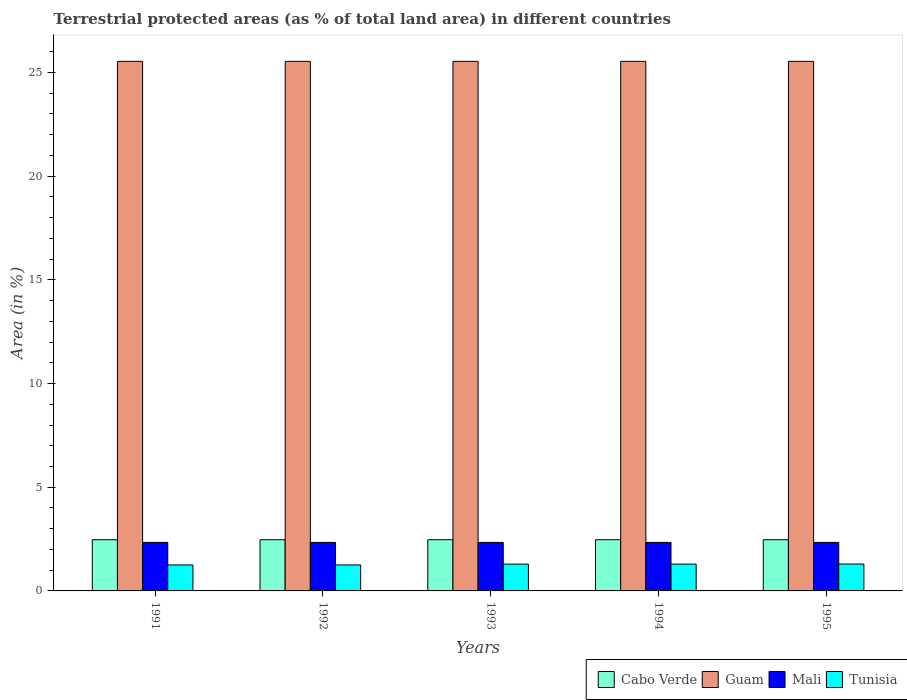How many groups of bars are there?
Keep it short and to the point. 5. How many bars are there on the 2nd tick from the left?
Offer a very short reply. 4. What is the label of the 1st group of bars from the left?
Make the answer very short. 1991. In how many cases, is the number of bars for a given year not equal to the number of legend labels?
Offer a very short reply. 0. What is the percentage of terrestrial protected land in Tunisia in 1995?
Make the answer very short. 1.3. Across all years, what is the maximum percentage of terrestrial protected land in Mali?
Provide a succinct answer. 2.34. Across all years, what is the minimum percentage of terrestrial protected land in Cabo Verde?
Your response must be concise. 2.47. In which year was the percentage of terrestrial protected land in Guam maximum?
Offer a terse response. 1991. In which year was the percentage of terrestrial protected land in Guam minimum?
Offer a terse response. 1991. What is the total percentage of terrestrial protected land in Mali in the graph?
Your answer should be very brief. 11.69. What is the difference between the percentage of terrestrial protected land in Guam in 1993 and the percentage of terrestrial protected land in Cabo Verde in 1995?
Your answer should be very brief. 23.07. What is the average percentage of terrestrial protected land in Tunisia per year?
Your response must be concise. 1.28. In the year 1995, what is the difference between the percentage of terrestrial protected land in Tunisia and percentage of terrestrial protected land in Cabo Verde?
Give a very brief answer. -1.17. What is the ratio of the percentage of terrestrial protected land in Guam in 1991 to that in 1995?
Give a very brief answer. 1. What is the difference between the highest and the second highest percentage of terrestrial protected land in Guam?
Keep it short and to the point. 0. What is the difference between the highest and the lowest percentage of terrestrial protected land in Guam?
Your response must be concise. 0. What does the 2nd bar from the left in 1994 represents?
Offer a terse response. Guam. What does the 3rd bar from the right in 1993 represents?
Your answer should be compact. Guam. Is it the case that in every year, the sum of the percentage of terrestrial protected land in Guam and percentage of terrestrial protected land in Tunisia is greater than the percentage of terrestrial protected land in Cabo Verde?
Give a very brief answer. Yes. Are all the bars in the graph horizontal?
Provide a succinct answer. No. Are the values on the major ticks of Y-axis written in scientific E-notation?
Make the answer very short. No. Does the graph contain any zero values?
Your answer should be compact. No. Where does the legend appear in the graph?
Keep it short and to the point. Bottom right. How are the legend labels stacked?
Your response must be concise. Horizontal. What is the title of the graph?
Make the answer very short. Terrestrial protected areas (as % of total land area) in different countries. Does "Gabon" appear as one of the legend labels in the graph?
Ensure brevity in your answer.  No. What is the label or title of the Y-axis?
Offer a terse response. Area (in %). What is the Area (in %) of Cabo Verde in 1991?
Provide a short and direct response. 2.47. What is the Area (in %) in Guam in 1991?
Your answer should be very brief. 25.54. What is the Area (in %) of Mali in 1991?
Provide a short and direct response. 2.34. What is the Area (in %) of Tunisia in 1991?
Offer a terse response. 1.25. What is the Area (in %) of Cabo Verde in 1992?
Ensure brevity in your answer.  2.47. What is the Area (in %) in Guam in 1992?
Keep it short and to the point. 25.54. What is the Area (in %) of Mali in 1992?
Provide a succinct answer. 2.34. What is the Area (in %) in Tunisia in 1992?
Your answer should be very brief. 1.25. What is the Area (in %) of Cabo Verde in 1993?
Keep it short and to the point. 2.47. What is the Area (in %) of Guam in 1993?
Provide a succinct answer. 25.54. What is the Area (in %) of Mali in 1993?
Your answer should be compact. 2.34. What is the Area (in %) of Tunisia in 1993?
Your answer should be compact. 1.29. What is the Area (in %) in Cabo Verde in 1994?
Keep it short and to the point. 2.47. What is the Area (in %) of Guam in 1994?
Your response must be concise. 25.54. What is the Area (in %) in Mali in 1994?
Ensure brevity in your answer.  2.34. What is the Area (in %) of Tunisia in 1994?
Your answer should be very brief. 1.29. What is the Area (in %) in Cabo Verde in 1995?
Your response must be concise. 2.47. What is the Area (in %) in Guam in 1995?
Ensure brevity in your answer.  25.54. What is the Area (in %) of Mali in 1995?
Your response must be concise. 2.34. What is the Area (in %) of Tunisia in 1995?
Provide a short and direct response. 1.3. Across all years, what is the maximum Area (in %) of Cabo Verde?
Your answer should be compact. 2.47. Across all years, what is the maximum Area (in %) of Guam?
Your answer should be compact. 25.54. Across all years, what is the maximum Area (in %) in Mali?
Provide a succinct answer. 2.34. Across all years, what is the maximum Area (in %) in Tunisia?
Offer a very short reply. 1.3. Across all years, what is the minimum Area (in %) of Cabo Verde?
Your answer should be very brief. 2.47. Across all years, what is the minimum Area (in %) in Guam?
Provide a succinct answer. 25.54. Across all years, what is the minimum Area (in %) in Mali?
Your answer should be very brief. 2.34. Across all years, what is the minimum Area (in %) of Tunisia?
Provide a short and direct response. 1.25. What is the total Area (in %) of Cabo Verde in the graph?
Keep it short and to the point. 12.34. What is the total Area (in %) of Guam in the graph?
Your answer should be compact. 127.69. What is the total Area (in %) in Mali in the graph?
Give a very brief answer. 11.69. What is the total Area (in %) of Tunisia in the graph?
Your response must be concise. 6.39. What is the difference between the Area (in %) of Tunisia in 1991 and that in 1992?
Your answer should be compact. 0. What is the difference between the Area (in %) of Cabo Verde in 1991 and that in 1993?
Provide a succinct answer. 0. What is the difference between the Area (in %) of Tunisia in 1991 and that in 1993?
Give a very brief answer. -0.04. What is the difference between the Area (in %) of Tunisia in 1991 and that in 1994?
Make the answer very short. -0.04. What is the difference between the Area (in %) in Cabo Verde in 1991 and that in 1995?
Ensure brevity in your answer.  0. What is the difference between the Area (in %) of Guam in 1991 and that in 1995?
Offer a very short reply. 0. What is the difference between the Area (in %) in Mali in 1991 and that in 1995?
Offer a very short reply. 0. What is the difference between the Area (in %) of Tunisia in 1991 and that in 1995?
Give a very brief answer. -0.04. What is the difference between the Area (in %) of Guam in 1992 and that in 1993?
Provide a succinct answer. 0. What is the difference between the Area (in %) of Tunisia in 1992 and that in 1993?
Your answer should be very brief. -0.04. What is the difference between the Area (in %) of Mali in 1992 and that in 1994?
Provide a succinct answer. 0. What is the difference between the Area (in %) of Tunisia in 1992 and that in 1994?
Give a very brief answer. -0.04. What is the difference between the Area (in %) in Cabo Verde in 1992 and that in 1995?
Ensure brevity in your answer.  0. What is the difference between the Area (in %) in Guam in 1992 and that in 1995?
Your answer should be very brief. 0. What is the difference between the Area (in %) in Tunisia in 1992 and that in 1995?
Make the answer very short. -0.04. What is the difference between the Area (in %) of Cabo Verde in 1993 and that in 1994?
Offer a very short reply. 0. What is the difference between the Area (in %) of Tunisia in 1993 and that in 1994?
Your response must be concise. 0. What is the difference between the Area (in %) of Guam in 1993 and that in 1995?
Ensure brevity in your answer.  0. What is the difference between the Area (in %) in Mali in 1993 and that in 1995?
Make the answer very short. 0. What is the difference between the Area (in %) of Tunisia in 1993 and that in 1995?
Provide a short and direct response. -0. What is the difference between the Area (in %) of Mali in 1994 and that in 1995?
Provide a succinct answer. 0. What is the difference between the Area (in %) in Tunisia in 1994 and that in 1995?
Offer a very short reply. -0. What is the difference between the Area (in %) in Cabo Verde in 1991 and the Area (in %) in Guam in 1992?
Provide a short and direct response. -23.07. What is the difference between the Area (in %) in Cabo Verde in 1991 and the Area (in %) in Mali in 1992?
Your answer should be very brief. 0.13. What is the difference between the Area (in %) in Cabo Verde in 1991 and the Area (in %) in Tunisia in 1992?
Your response must be concise. 1.22. What is the difference between the Area (in %) of Guam in 1991 and the Area (in %) of Mali in 1992?
Your response must be concise. 23.2. What is the difference between the Area (in %) in Guam in 1991 and the Area (in %) in Tunisia in 1992?
Provide a short and direct response. 24.28. What is the difference between the Area (in %) of Mali in 1991 and the Area (in %) of Tunisia in 1992?
Provide a succinct answer. 1.08. What is the difference between the Area (in %) in Cabo Verde in 1991 and the Area (in %) in Guam in 1993?
Keep it short and to the point. -23.07. What is the difference between the Area (in %) of Cabo Verde in 1991 and the Area (in %) of Mali in 1993?
Your answer should be compact. 0.13. What is the difference between the Area (in %) of Cabo Verde in 1991 and the Area (in %) of Tunisia in 1993?
Make the answer very short. 1.17. What is the difference between the Area (in %) of Guam in 1991 and the Area (in %) of Mali in 1993?
Your response must be concise. 23.2. What is the difference between the Area (in %) of Guam in 1991 and the Area (in %) of Tunisia in 1993?
Your response must be concise. 24.24. What is the difference between the Area (in %) in Mali in 1991 and the Area (in %) in Tunisia in 1993?
Your answer should be compact. 1.04. What is the difference between the Area (in %) in Cabo Verde in 1991 and the Area (in %) in Guam in 1994?
Offer a very short reply. -23.07. What is the difference between the Area (in %) in Cabo Verde in 1991 and the Area (in %) in Mali in 1994?
Make the answer very short. 0.13. What is the difference between the Area (in %) of Cabo Verde in 1991 and the Area (in %) of Tunisia in 1994?
Keep it short and to the point. 1.17. What is the difference between the Area (in %) in Guam in 1991 and the Area (in %) in Mali in 1994?
Keep it short and to the point. 23.2. What is the difference between the Area (in %) in Guam in 1991 and the Area (in %) in Tunisia in 1994?
Your answer should be compact. 24.24. What is the difference between the Area (in %) of Mali in 1991 and the Area (in %) of Tunisia in 1994?
Ensure brevity in your answer.  1.04. What is the difference between the Area (in %) of Cabo Verde in 1991 and the Area (in %) of Guam in 1995?
Keep it short and to the point. -23.07. What is the difference between the Area (in %) of Cabo Verde in 1991 and the Area (in %) of Mali in 1995?
Provide a short and direct response. 0.13. What is the difference between the Area (in %) of Cabo Verde in 1991 and the Area (in %) of Tunisia in 1995?
Make the answer very short. 1.17. What is the difference between the Area (in %) in Guam in 1991 and the Area (in %) in Mali in 1995?
Provide a succinct answer. 23.2. What is the difference between the Area (in %) in Guam in 1991 and the Area (in %) in Tunisia in 1995?
Make the answer very short. 24.24. What is the difference between the Area (in %) of Mali in 1991 and the Area (in %) of Tunisia in 1995?
Provide a succinct answer. 1.04. What is the difference between the Area (in %) in Cabo Verde in 1992 and the Area (in %) in Guam in 1993?
Give a very brief answer. -23.07. What is the difference between the Area (in %) in Cabo Verde in 1992 and the Area (in %) in Mali in 1993?
Provide a short and direct response. 0.13. What is the difference between the Area (in %) in Cabo Verde in 1992 and the Area (in %) in Tunisia in 1993?
Provide a succinct answer. 1.17. What is the difference between the Area (in %) in Guam in 1992 and the Area (in %) in Mali in 1993?
Offer a terse response. 23.2. What is the difference between the Area (in %) of Guam in 1992 and the Area (in %) of Tunisia in 1993?
Ensure brevity in your answer.  24.24. What is the difference between the Area (in %) of Mali in 1992 and the Area (in %) of Tunisia in 1993?
Make the answer very short. 1.04. What is the difference between the Area (in %) of Cabo Verde in 1992 and the Area (in %) of Guam in 1994?
Offer a very short reply. -23.07. What is the difference between the Area (in %) of Cabo Verde in 1992 and the Area (in %) of Mali in 1994?
Keep it short and to the point. 0.13. What is the difference between the Area (in %) in Cabo Verde in 1992 and the Area (in %) in Tunisia in 1994?
Keep it short and to the point. 1.17. What is the difference between the Area (in %) of Guam in 1992 and the Area (in %) of Mali in 1994?
Ensure brevity in your answer.  23.2. What is the difference between the Area (in %) in Guam in 1992 and the Area (in %) in Tunisia in 1994?
Your answer should be very brief. 24.24. What is the difference between the Area (in %) in Mali in 1992 and the Area (in %) in Tunisia in 1994?
Ensure brevity in your answer.  1.04. What is the difference between the Area (in %) of Cabo Verde in 1992 and the Area (in %) of Guam in 1995?
Your answer should be very brief. -23.07. What is the difference between the Area (in %) of Cabo Verde in 1992 and the Area (in %) of Mali in 1995?
Ensure brevity in your answer.  0.13. What is the difference between the Area (in %) in Cabo Verde in 1992 and the Area (in %) in Tunisia in 1995?
Ensure brevity in your answer.  1.17. What is the difference between the Area (in %) in Guam in 1992 and the Area (in %) in Mali in 1995?
Keep it short and to the point. 23.2. What is the difference between the Area (in %) of Guam in 1992 and the Area (in %) of Tunisia in 1995?
Give a very brief answer. 24.24. What is the difference between the Area (in %) of Mali in 1992 and the Area (in %) of Tunisia in 1995?
Your answer should be very brief. 1.04. What is the difference between the Area (in %) in Cabo Verde in 1993 and the Area (in %) in Guam in 1994?
Provide a short and direct response. -23.07. What is the difference between the Area (in %) of Cabo Verde in 1993 and the Area (in %) of Mali in 1994?
Provide a succinct answer. 0.13. What is the difference between the Area (in %) of Cabo Verde in 1993 and the Area (in %) of Tunisia in 1994?
Provide a succinct answer. 1.17. What is the difference between the Area (in %) in Guam in 1993 and the Area (in %) in Mali in 1994?
Provide a succinct answer. 23.2. What is the difference between the Area (in %) of Guam in 1993 and the Area (in %) of Tunisia in 1994?
Provide a short and direct response. 24.24. What is the difference between the Area (in %) of Mali in 1993 and the Area (in %) of Tunisia in 1994?
Your response must be concise. 1.04. What is the difference between the Area (in %) of Cabo Verde in 1993 and the Area (in %) of Guam in 1995?
Your answer should be compact. -23.07. What is the difference between the Area (in %) in Cabo Verde in 1993 and the Area (in %) in Mali in 1995?
Your response must be concise. 0.13. What is the difference between the Area (in %) of Cabo Verde in 1993 and the Area (in %) of Tunisia in 1995?
Give a very brief answer. 1.17. What is the difference between the Area (in %) in Guam in 1993 and the Area (in %) in Mali in 1995?
Provide a short and direct response. 23.2. What is the difference between the Area (in %) in Guam in 1993 and the Area (in %) in Tunisia in 1995?
Give a very brief answer. 24.24. What is the difference between the Area (in %) of Mali in 1993 and the Area (in %) of Tunisia in 1995?
Offer a terse response. 1.04. What is the difference between the Area (in %) of Cabo Verde in 1994 and the Area (in %) of Guam in 1995?
Offer a terse response. -23.07. What is the difference between the Area (in %) in Cabo Verde in 1994 and the Area (in %) in Mali in 1995?
Your answer should be compact. 0.13. What is the difference between the Area (in %) in Cabo Verde in 1994 and the Area (in %) in Tunisia in 1995?
Make the answer very short. 1.17. What is the difference between the Area (in %) in Guam in 1994 and the Area (in %) in Mali in 1995?
Provide a short and direct response. 23.2. What is the difference between the Area (in %) in Guam in 1994 and the Area (in %) in Tunisia in 1995?
Make the answer very short. 24.24. What is the difference between the Area (in %) in Mali in 1994 and the Area (in %) in Tunisia in 1995?
Ensure brevity in your answer.  1.04. What is the average Area (in %) of Cabo Verde per year?
Make the answer very short. 2.47. What is the average Area (in %) of Guam per year?
Provide a short and direct response. 25.54. What is the average Area (in %) of Mali per year?
Provide a short and direct response. 2.34. What is the average Area (in %) in Tunisia per year?
Give a very brief answer. 1.28. In the year 1991, what is the difference between the Area (in %) in Cabo Verde and Area (in %) in Guam?
Your response must be concise. -23.07. In the year 1991, what is the difference between the Area (in %) in Cabo Verde and Area (in %) in Mali?
Your answer should be very brief. 0.13. In the year 1991, what is the difference between the Area (in %) in Cabo Verde and Area (in %) in Tunisia?
Your response must be concise. 1.22. In the year 1991, what is the difference between the Area (in %) in Guam and Area (in %) in Mali?
Keep it short and to the point. 23.2. In the year 1991, what is the difference between the Area (in %) in Guam and Area (in %) in Tunisia?
Give a very brief answer. 24.28. In the year 1991, what is the difference between the Area (in %) in Mali and Area (in %) in Tunisia?
Offer a terse response. 1.08. In the year 1992, what is the difference between the Area (in %) in Cabo Verde and Area (in %) in Guam?
Provide a short and direct response. -23.07. In the year 1992, what is the difference between the Area (in %) of Cabo Verde and Area (in %) of Mali?
Your answer should be compact. 0.13. In the year 1992, what is the difference between the Area (in %) in Cabo Verde and Area (in %) in Tunisia?
Your answer should be very brief. 1.22. In the year 1992, what is the difference between the Area (in %) in Guam and Area (in %) in Mali?
Your answer should be compact. 23.2. In the year 1992, what is the difference between the Area (in %) of Guam and Area (in %) of Tunisia?
Your response must be concise. 24.28. In the year 1992, what is the difference between the Area (in %) in Mali and Area (in %) in Tunisia?
Your answer should be compact. 1.08. In the year 1993, what is the difference between the Area (in %) of Cabo Verde and Area (in %) of Guam?
Your answer should be very brief. -23.07. In the year 1993, what is the difference between the Area (in %) in Cabo Verde and Area (in %) in Mali?
Offer a terse response. 0.13. In the year 1993, what is the difference between the Area (in %) of Cabo Verde and Area (in %) of Tunisia?
Offer a very short reply. 1.17. In the year 1993, what is the difference between the Area (in %) of Guam and Area (in %) of Mali?
Ensure brevity in your answer.  23.2. In the year 1993, what is the difference between the Area (in %) in Guam and Area (in %) in Tunisia?
Provide a succinct answer. 24.24. In the year 1993, what is the difference between the Area (in %) in Mali and Area (in %) in Tunisia?
Provide a succinct answer. 1.04. In the year 1994, what is the difference between the Area (in %) in Cabo Verde and Area (in %) in Guam?
Ensure brevity in your answer.  -23.07. In the year 1994, what is the difference between the Area (in %) of Cabo Verde and Area (in %) of Mali?
Your answer should be compact. 0.13. In the year 1994, what is the difference between the Area (in %) of Cabo Verde and Area (in %) of Tunisia?
Your answer should be compact. 1.17. In the year 1994, what is the difference between the Area (in %) of Guam and Area (in %) of Mali?
Ensure brevity in your answer.  23.2. In the year 1994, what is the difference between the Area (in %) of Guam and Area (in %) of Tunisia?
Offer a very short reply. 24.24. In the year 1994, what is the difference between the Area (in %) in Mali and Area (in %) in Tunisia?
Keep it short and to the point. 1.04. In the year 1995, what is the difference between the Area (in %) in Cabo Verde and Area (in %) in Guam?
Offer a terse response. -23.07. In the year 1995, what is the difference between the Area (in %) in Cabo Verde and Area (in %) in Mali?
Ensure brevity in your answer.  0.13. In the year 1995, what is the difference between the Area (in %) of Cabo Verde and Area (in %) of Tunisia?
Your answer should be compact. 1.17. In the year 1995, what is the difference between the Area (in %) in Guam and Area (in %) in Mali?
Offer a terse response. 23.2. In the year 1995, what is the difference between the Area (in %) in Guam and Area (in %) in Tunisia?
Give a very brief answer. 24.24. In the year 1995, what is the difference between the Area (in %) in Mali and Area (in %) in Tunisia?
Ensure brevity in your answer.  1.04. What is the ratio of the Area (in %) of Guam in 1991 to that in 1992?
Your answer should be very brief. 1. What is the ratio of the Area (in %) in Mali in 1991 to that in 1992?
Offer a very short reply. 1. What is the ratio of the Area (in %) in Cabo Verde in 1991 to that in 1993?
Keep it short and to the point. 1. What is the ratio of the Area (in %) in Tunisia in 1991 to that in 1993?
Ensure brevity in your answer.  0.97. What is the ratio of the Area (in %) in Cabo Verde in 1991 to that in 1994?
Provide a succinct answer. 1. What is the ratio of the Area (in %) in Guam in 1991 to that in 1994?
Keep it short and to the point. 1. What is the ratio of the Area (in %) in Tunisia in 1991 to that in 1994?
Give a very brief answer. 0.97. What is the ratio of the Area (in %) in Cabo Verde in 1991 to that in 1995?
Provide a short and direct response. 1. What is the ratio of the Area (in %) in Guam in 1991 to that in 1995?
Your answer should be very brief. 1. What is the ratio of the Area (in %) of Mali in 1991 to that in 1995?
Ensure brevity in your answer.  1. What is the ratio of the Area (in %) of Tunisia in 1991 to that in 1995?
Your answer should be very brief. 0.97. What is the ratio of the Area (in %) in Tunisia in 1992 to that in 1993?
Keep it short and to the point. 0.97. What is the ratio of the Area (in %) of Cabo Verde in 1992 to that in 1994?
Your answer should be very brief. 1. What is the ratio of the Area (in %) of Tunisia in 1992 to that in 1994?
Your response must be concise. 0.97. What is the ratio of the Area (in %) in Mali in 1992 to that in 1995?
Your response must be concise. 1. What is the ratio of the Area (in %) in Tunisia in 1992 to that in 1995?
Your response must be concise. 0.97. What is the ratio of the Area (in %) in Cabo Verde in 1993 to that in 1994?
Provide a succinct answer. 1. What is the ratio of the Area (in %) of Guam in 1993 to that in 1994?
Provide a short and direct response. 1. What is the ratio of the Area (in %) in Mali in 1993 to that in 1994?
Keep it short and to the point. 1. What is the ratio of the Area (in %) of Tunisia in 1993 to that in 1994?
Your response must be concise. 1. What is the ratio of the Area (in %) of Cabo Verde in 1993 to that in 1995?
Provide a short and direct response. 1. What is the ratio of the Area (in %) of Tunisia in 1993 to that in 1995?
Keep it short and to the point. 1. What is the ratio of the Area (in %) in Cabo Verde in 1994 to that in 1995?
Make the answer very short. 1. What is the ratio of the Area (in %) in Guam in 1994 to that in 1995?
Provide a short and direct response. 1. What is the ratio of the Area (in %) in Mali in 1994 to that in 1995?
Your answer should be compact. 1. What is the difference between the highest and the second highest Area (in %) in Cabo Verde?
Provide a short and direct response. 0. What is the difference between the highest and the second highest Area (in %) in Guam?
Your answer should be compact. 0. What is the difference between the highest and the second highest Area (in %) of Tunisia?
Make the answer very short. 0. What is the difference between the highest and the lowest Area (in %) of Tunisia?
Offer a very short reply. 0.04. 